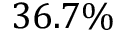Convert formula to latex. <formula><loc_0><loc_0><loc_500><loc_500>3 6 . 7 \%</formula> 